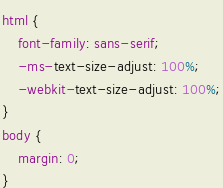Convert code to text. <code><loc_0><loc_0><loc_500><loc_500><_CSS_>html {
    font-family: sans-serif;
    -ms-text-size-adjust: 100%;
    -webkit-text-size-adjust: 100%;
}
body {
    margin: 0;
}
</code> 